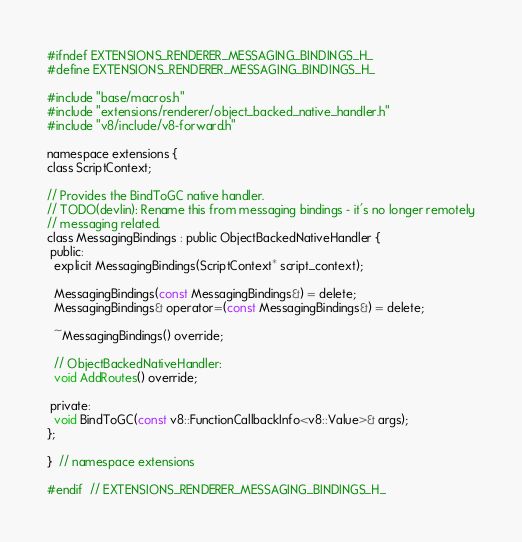Convert code to text. <code><loc_0><loc_0><loc_500><loc_500><_C_>
#ifndef EXTENSIONS_RENDERER_MESSAGING_BINDINGS_H_
#define EXTENSIONS_RENDERER_MESSAGING_BINDINGS_H_

#include "base/macros.h"
#include "extensions/renderer/object_backed_native_handler.h"
#include "v8/include/v8-forward.h"

namespace extensions {
class ScriptContext;

// Provides the BindToGC native handler.
// TODO(devlin): Rename this from messaging bindings - it's no longer remotely
// messaging related.
class MessagingBindings : public ObjectBackedNativeHandler {
 public:
  explicit MessagingBindings(ScriptContext* script_context);

  MessagingBindings(const MessagingBindings&) = delete;
  MessagingBindings& operator=(const MessagingBindings&) = delete;

  ~MessagingBindings() override;

  // ObjectBackedNativeHandler:
  void AddRoutes() override;

 private:
  void BindToGC(const v8::FunctionCallbackInfo<v8::Value>& args);
};

}  // namespace extensions

#endif  // EXTENSIONS_RENDERER_MESSAGING_BINDINGS_H_
</code> 